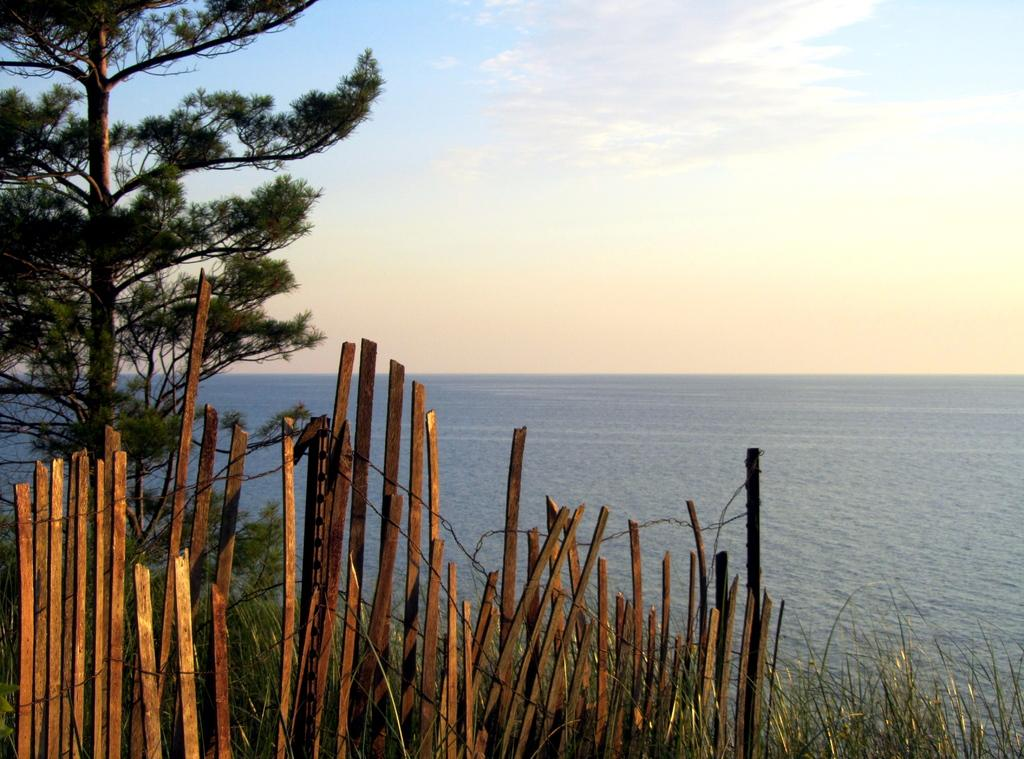What type of barrier can be seen in the image? There is a wooden fence in the image. What type of vegetation is present in the image? There is grass and a tree in the image. What is the water feature in the image? The water is visible in the image. What is visible in the background of the image? The sky is visible in the background of the image. What can be seen in the sky? There are clouds in the sky. Can you see a collar on the tree in the image? There is no collar present on the tree in the image. How many items are on a list in the image? There is no list present in the image. 